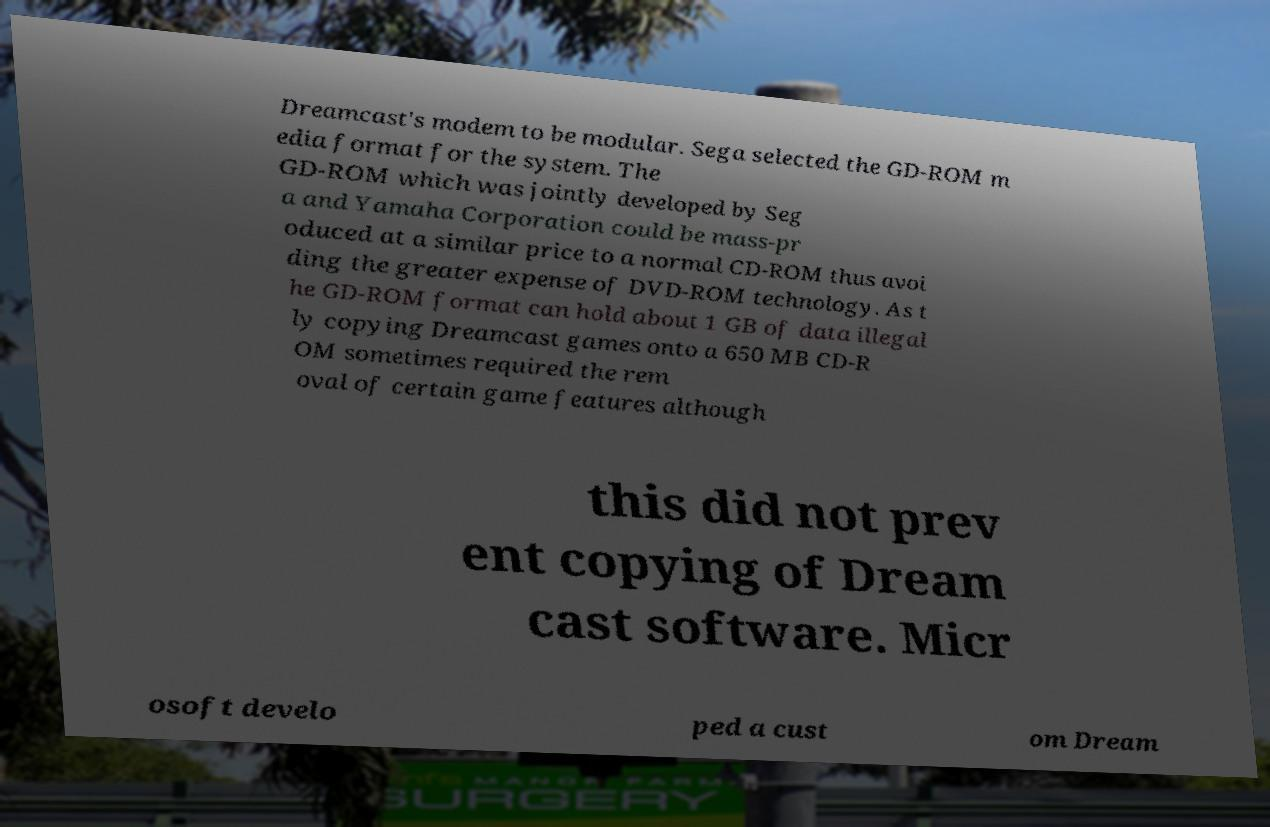I need the written content from this picture converted into text. Can you do that? Dreamcast's modem to be modular. Sega selected the GD-ROM m edia format for the system. The GD-ROM which was jointly developed by Seg a and Yamaha Corporation could be mass-pr oduced at a similar price to a normal CD-ROM thus avoi ding the greater expense of DVD-ROM technology. As t he GD-ROM format can hold about 1 GB of data illegal ly copying Dreamcast games onto a 650 MB CD-R OM sometimes required the rem oval of certain game features although this did not prev ent copying of Dream cast software. Micr osoft develo ped a cust om Dream 